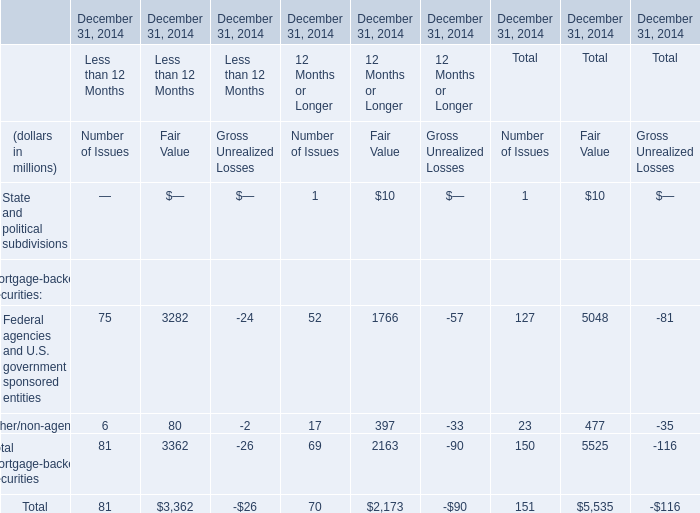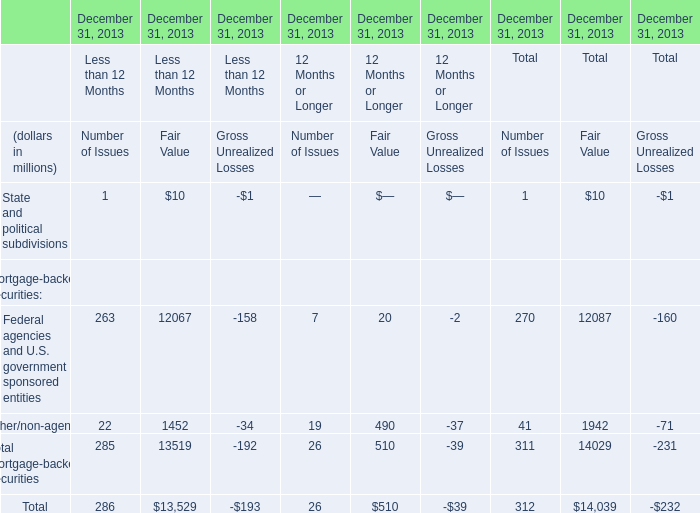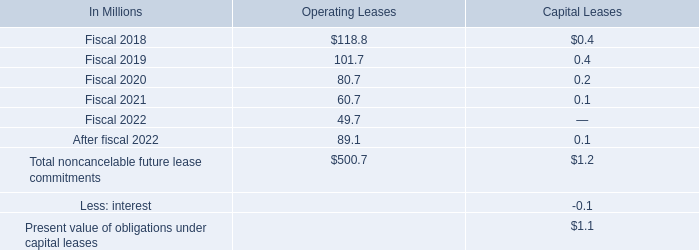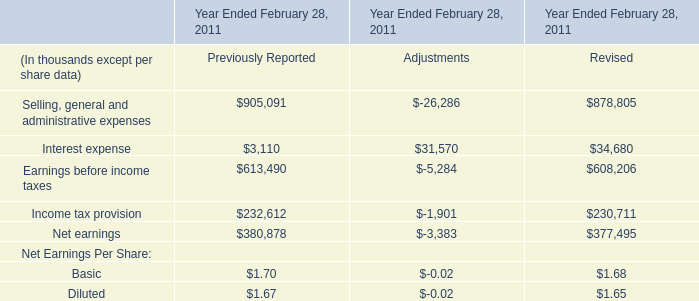what is the change in balance of accrued interest and penalties from 2016 to 2017? 
Computations: (23.1 - 32.1)
Answer: -9.0. 